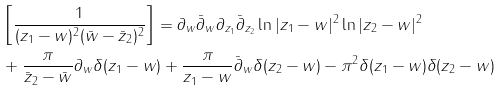<formula> <loc_0><loc_0><loc_500><loc_500>& \left [ \frac { 1 } { ( z _ { 1 } - w ) ^ { 2 } ( \bar { w } - \bar { z } _ { 2 } ) ^ { 2 } } \right ] = \partial _ { w } \bar { \partial } _ { w } \partial _ { z _ { 1 } } \bar { \partial } _ { z _ { 2 } } \ln | z _ { 1 } - w | ^ { 2 } \ln | z _ { 2 } - w | ^ { 2 } \\ & + \frac { \pi } { \bar { z } _ { 2 } - \bar { w } } \partial _ { w } \delta ( z _ { 1 } - w ) + \frac { \pi } { z _ { 1 } - w } \bar { \partial } _ { w } \delta ( z _ { 2 } - w ) - \pi ^ { 2 } \delta ( z _ { 1 } - w ) \delta ( z _ { 2 } - w )</formula> 